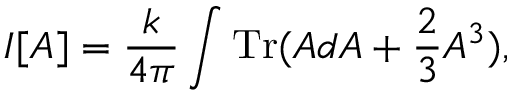Convert formula to latex. <formula><loc_0><loc_0><loc_500><loc_500>I [ A ] = \frac { k } { 4 \pi } \int T r ( A d A + \frac { 2 } { 3 } A ^ { 3 } ) ,</formula> 